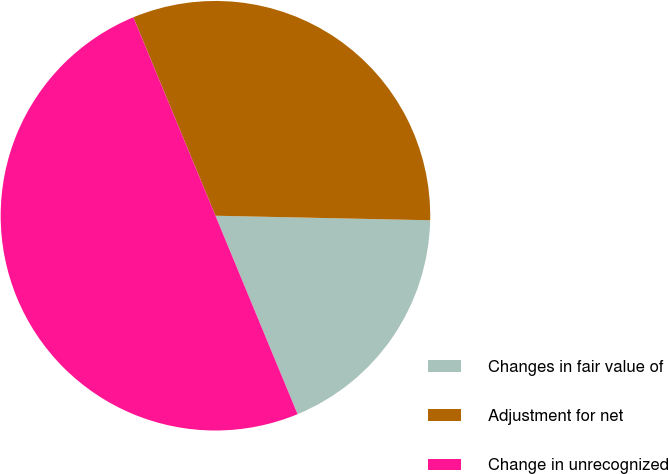Convert chart to OTSL. <chart><loc_0><loc_0><loc_500><loc_500><pie_chart><fcel>Changes in fair value of<fcel>Adjustment for net<fcel>Change in unrecognized<nl><fcel>18.42%<fcel>31.58%<fcel>50.0%<nl></chart> 